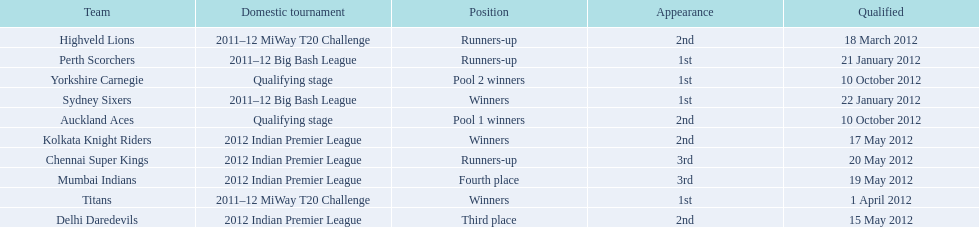Which team came in after the titans in the miway t20 challenge? Highveld Lions. 